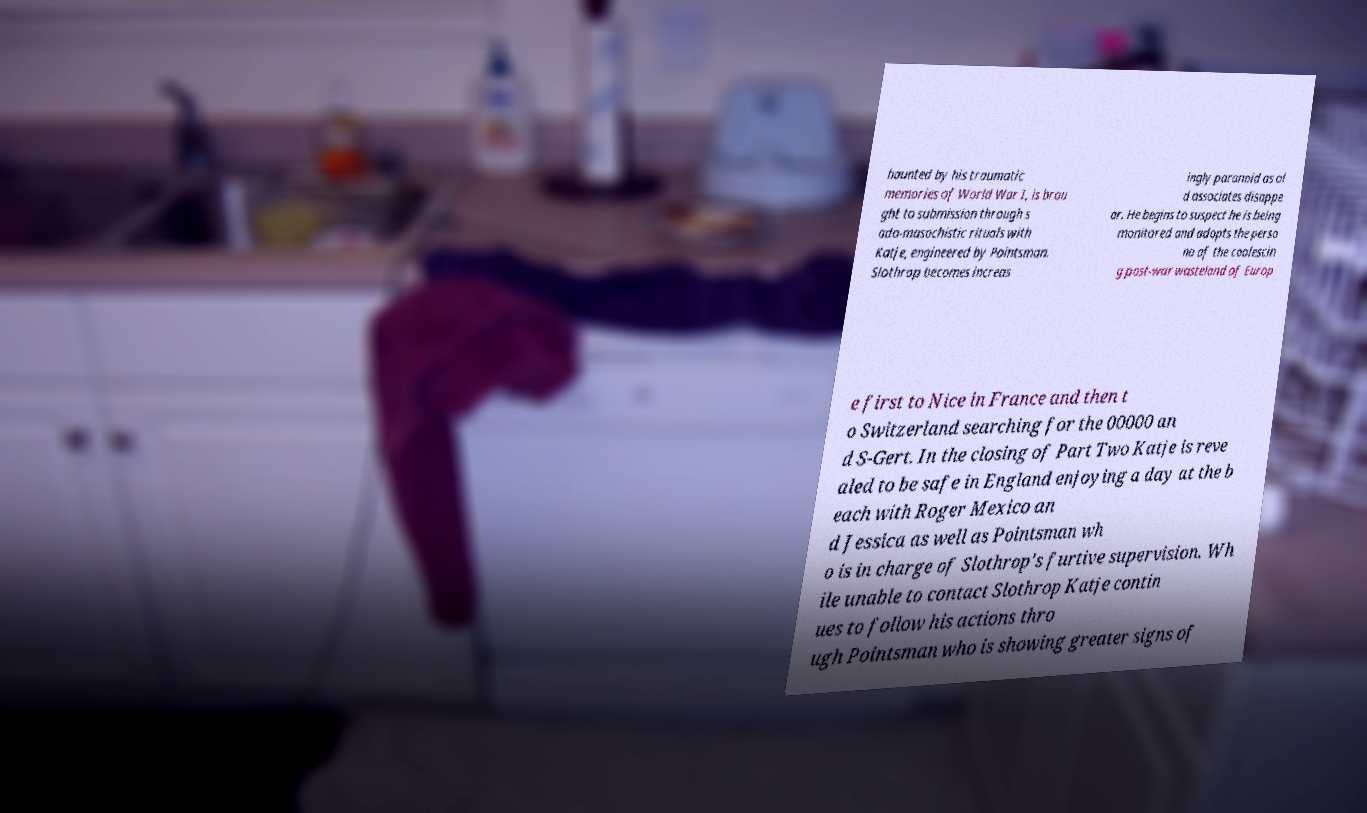Can you read and provide the text displayed in the image?This photo seems to have some interesting text. Can you extract and type it out for me? haunted by his traumatic memories of World War I, is brou ght to submission through s ado-masochistic rituals with Katje, engineered by Pointsman. Slothrop becomes increas ingly paranoid as ol d associates disappe ar. He begins to suspect he is being monitored and adopts the perso na of the coalescin g post-war wasteland of Europ e first to Nice in France and then t o Switzerland searching for the 00000 an d S-Gert. In the closing of Part Two Katje is reve aled to be safe in England enjoying a day at the b each with Roger Mexico an d Jessica as well as Pointsman wh o is in charge of Slothrop's furtive supervision. Wh ile unable to contact Slothrop Katje contin ues to follow his actions thro ugh Pointsman who is showing greater signs of 